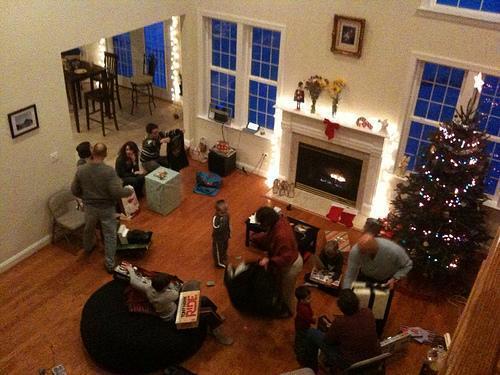How many pictures are hung on the walls?
Give a very brief answer. 2. How many people are there?
Give a very brief answer. 11. How many children are present?
Give a very brief answer. 3. How many windows are visible?
Give a very brief answer. 5. How many people are there?
Give a very brief answer. 5. 